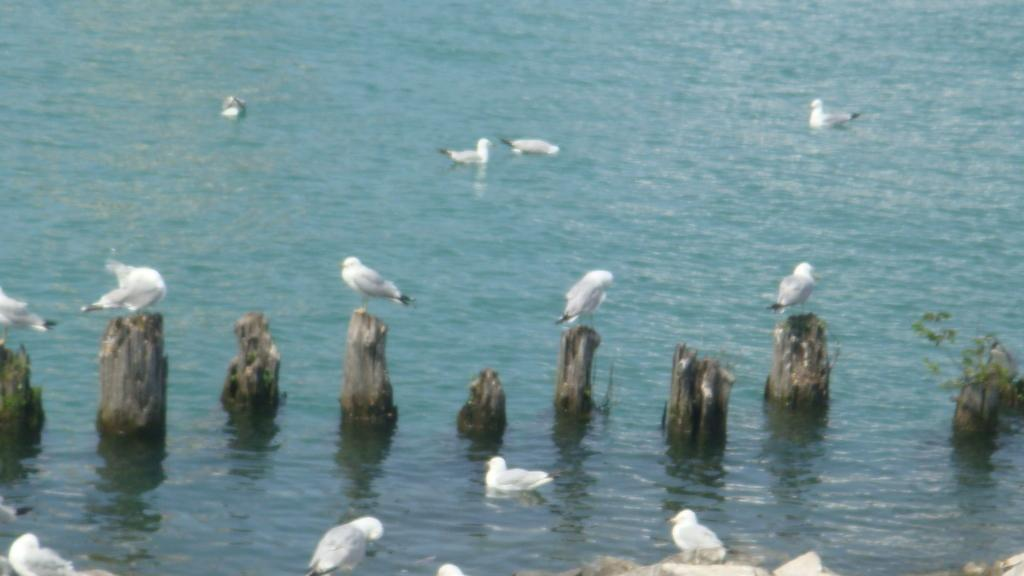What is the primary element in the image? The image consists of water. What animals can be seen in the image? There are cranes and ducks in the image. Where are the cranes and ducks located in the image? The cranes and ducks are in the middle of the image. What color are the cranes and ducks in the image? The cranes and ducks are white in color. What type of feather can be seen on the ducks in the image? There is no specific feather mentioned or visible in the image; only the color of the cranes and ducks is mentioned. 